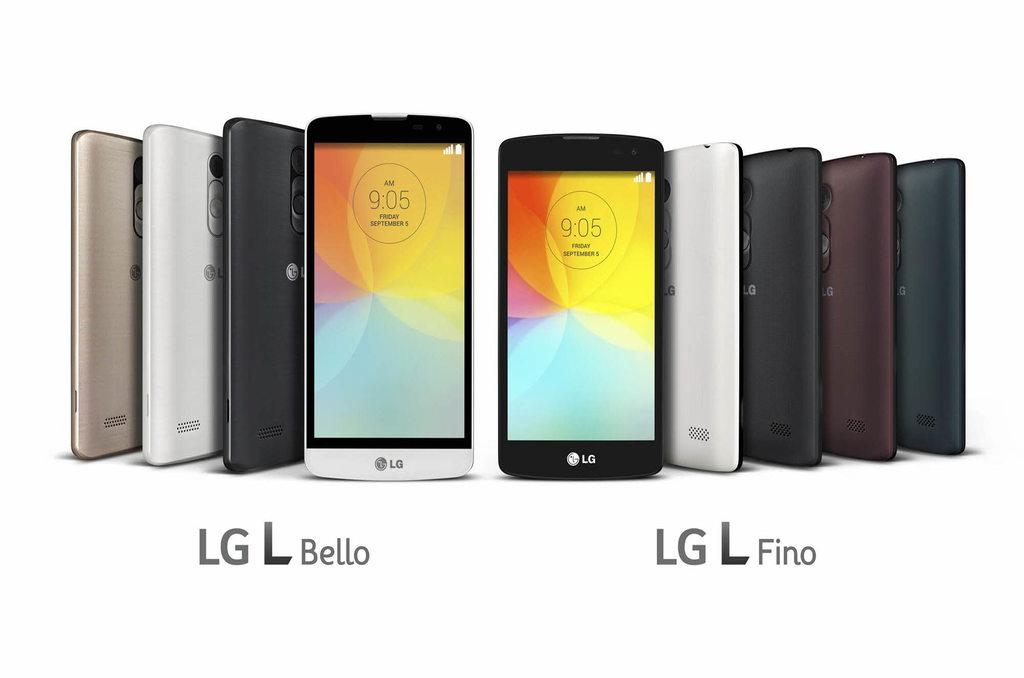Provide a one-sentence caption for the provided image. LG L Bello phones on the left and LG L Fino phones on the right are standing upright against a white background. 